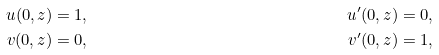<formula> <loc_0><loc_0><loc_500><loc_500>u ( 0 , z ) = 1 , & & u ^ { \prime } ( 0 , z ) = 0 , \\ v ( 0 , z ) = 0 , & & v ^ { \prime } ( 0 , z ) = 1 ,</formula> 